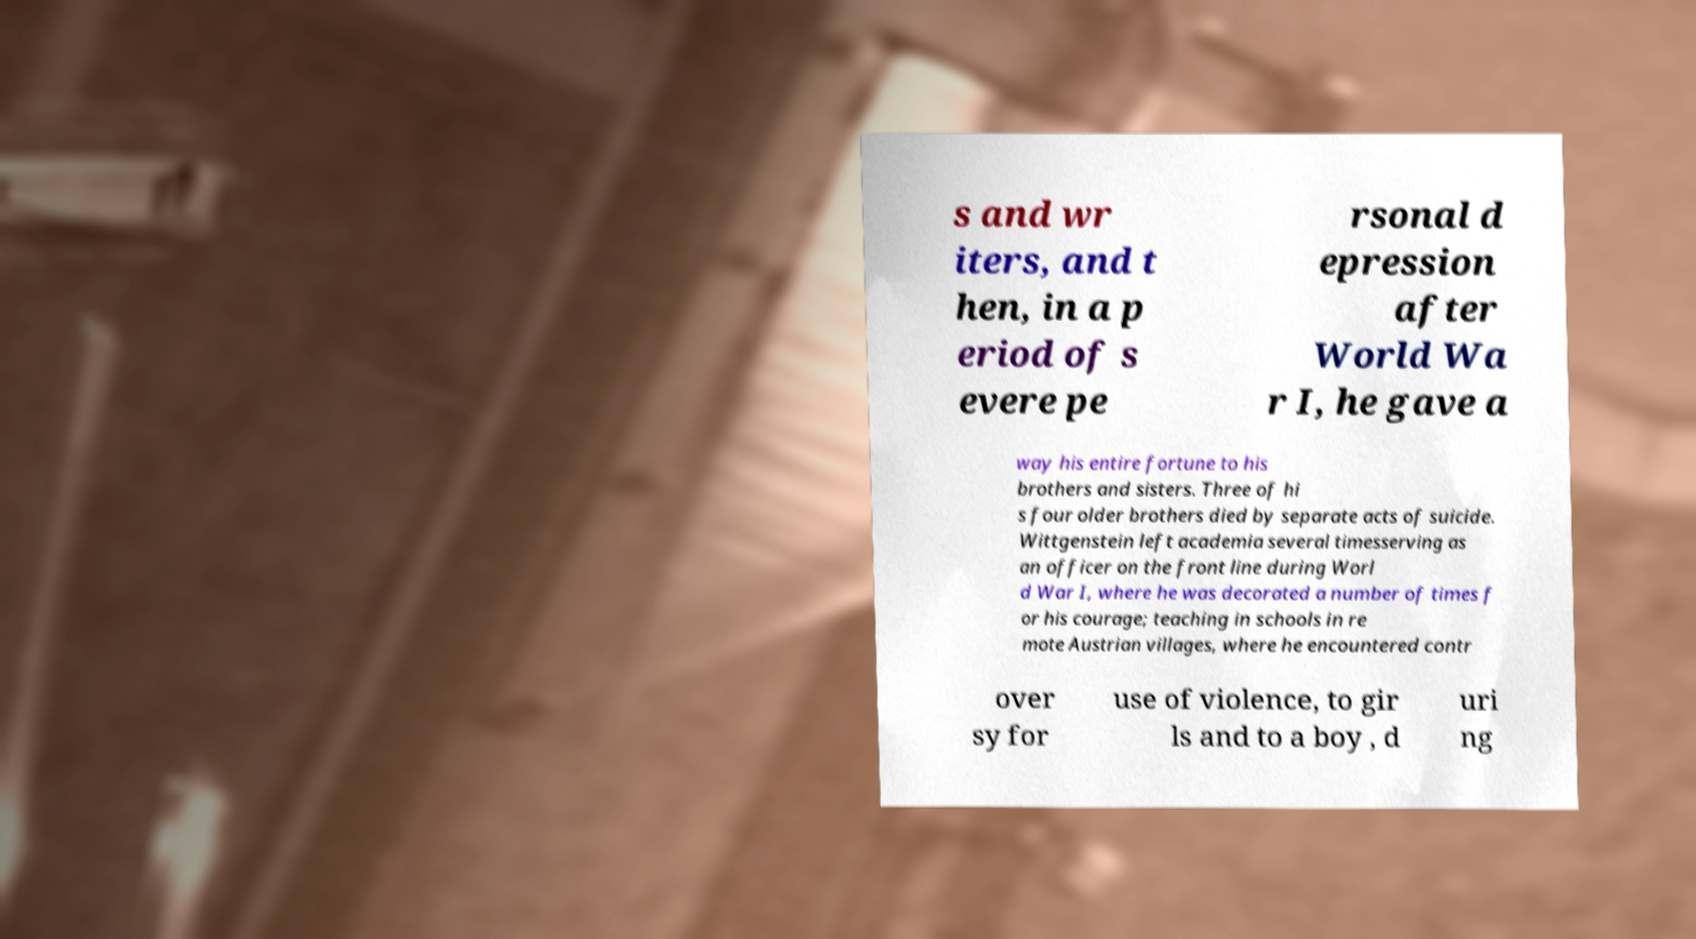Can you read and provide the text displayed in the image?This photo seems to have some interesting text. Can you extract and type it out for me? s and wr iters, and t hen, in a p eriod of s evere pe rsonal d epression after World Wa r I, he gave a way his entire fortune to his brothers and sisters. Three of hi s four older brothers died by separate acts of suicide. Wittgenstein left academia several timesserving as an officer on the front line during Worl d War I, where he was decorated a number of times f or his courage; teaching in schools in re mote Austrian villages, where he encountered contr over sy for use of violence, to gir ls and to a boy , d uri ng 